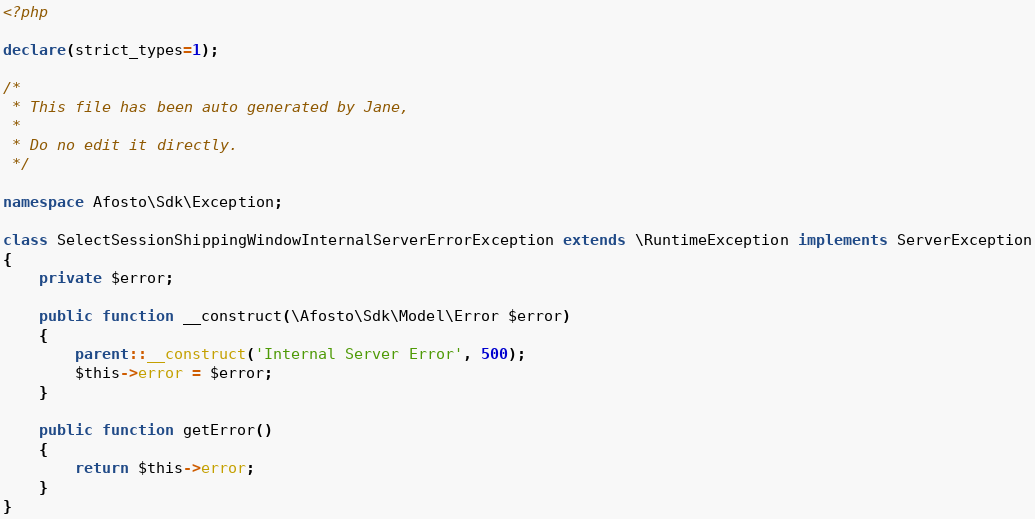Convert code to text. <code><loc_0><loc_0><loc_500><loc_500><_PHP_><?php

declare(strict_types=1);

/*
 * This file has been auto generated by Jane,
 *
 * Do no edit it directly.
 */

namespace Afosto\Sdk\Exception;

class SelectSessionShippingWindowInternalServerErrorException extends \RuntimeException implements ServerException
{
    private $error;

    public function __construct(\Afosto\Sdk\Model\Error $error)
    {
        parent::__construct('Internal Server Error', 500);
        $this->error = $error;
    }

    public function getError()
    {
        return $this->error;
    }
}
</code> 